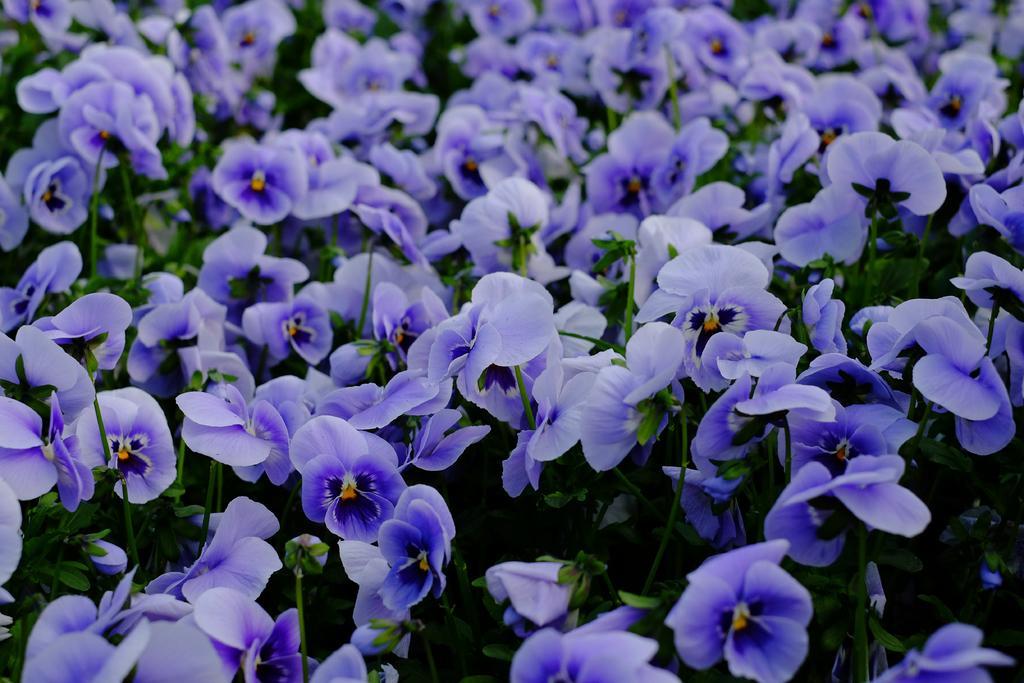Describe this image in one or two sentences. In this picture we can see flowers and plants. 